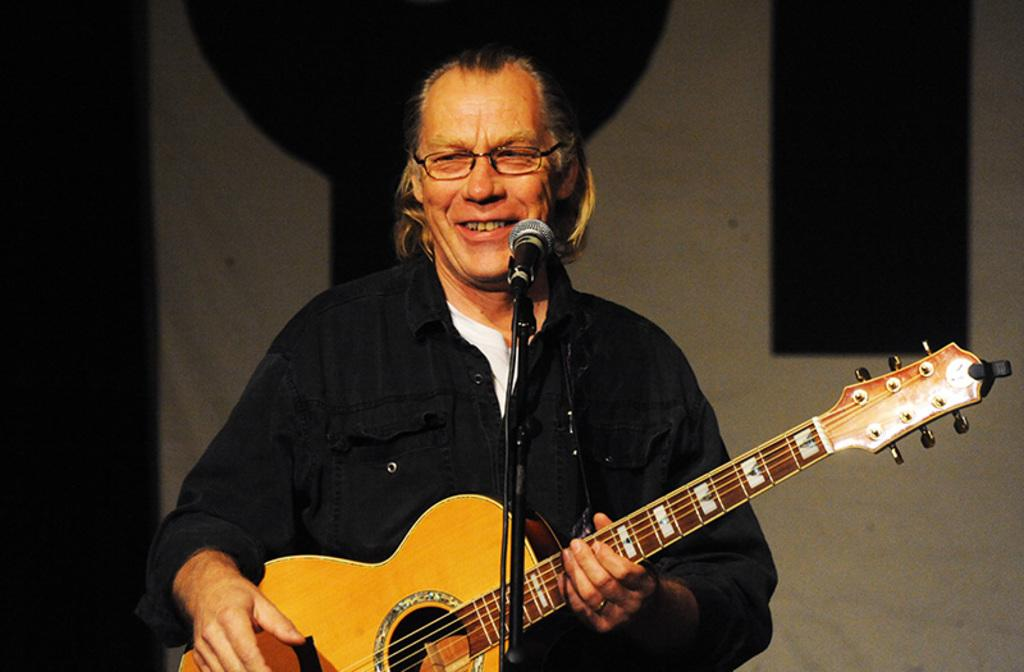Who is the main subject in the image? There is a man in the image. What can be observed about the man's appearance? The man is wearing spectacles. How is the man feeling in the image? The man has a smile on his face. What is the man doing in the image? The man is standing in front of a microphone and playing a guitar. What type of bottle is the man holding in the image? There is no bottle present in the image. Is the man celebrating a birthday in the image? There is no indication of a birthday celebration in the image. 